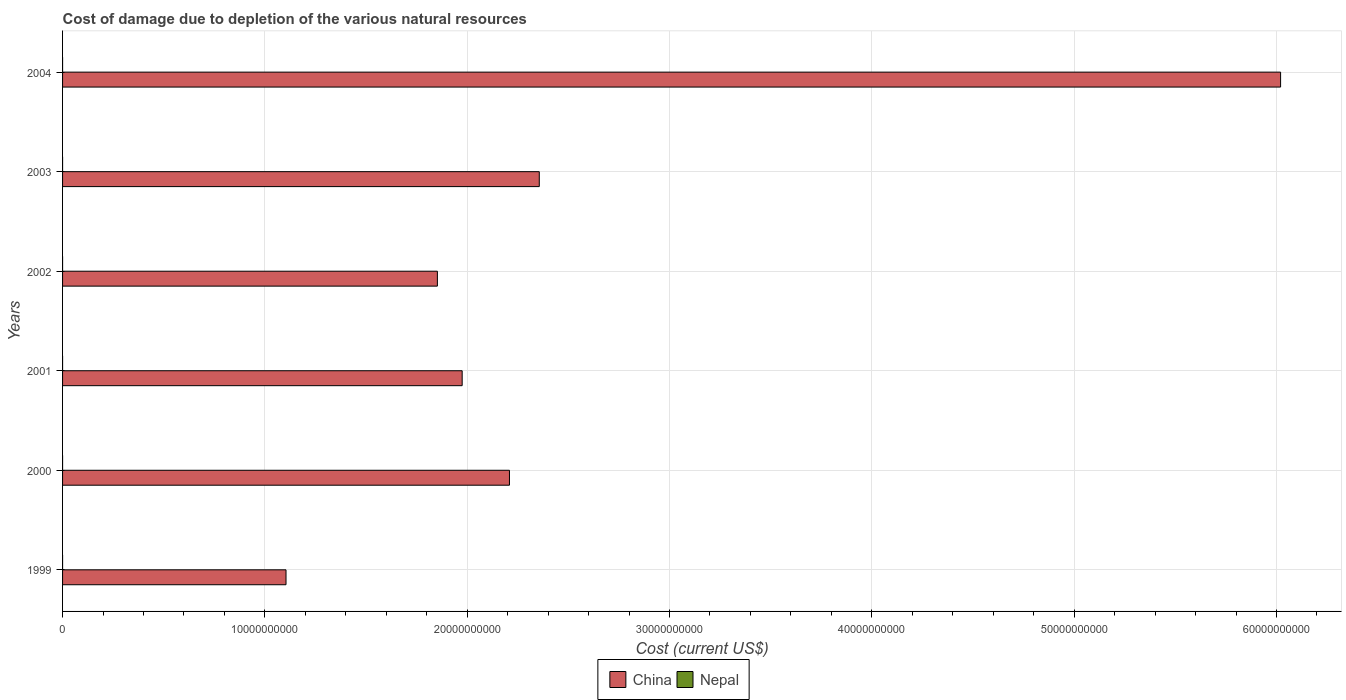How many different coloured bars are there?
Keep it short and to the point. 2. How many groups of bars are there?
Provide a succinct answer. 6. What is the cost of damage caused due to the depletion of various natural resources in China in 2004?
Your answer should be compact. 6.02e+1. Across all years, what is the maximum cost of damage caused due to the depletion of various natural resources in China?
Offer a terse response. 6.02e+1. Across all years, what is the minimum cost of damage caused due to the depletion of various natural resources in Nepal?
Ensure brevity in your answer.  4670.54. In which year was the cost of damage caused due to the depletion of various natural resources in Nepal maximum?
Your answer should be very brief. 2004. In which year was the cost of damage caused due to the depletion of various natural resources in Nepal minimum?
Ensure brevity in your answer.  1999. What is the total cost of damage caused due to the depletion of various natural resources in China in the graph?
Your answer should be compact. 1.55e+11. What is the difference between the cost of damage caused due to the depletion of various natural resources in Nepal in 1999 and that in 2001?
Offer a terse response. -5.87e+04. What is the difference between the cost of damage caused due to the depletion of various natural resources in Nepal in 2000 and the cost of damage caused due to the depletion of various natural resources in China in 2001?
Your answer should be very brief. -1.98e+1. What is the average cost of damage caused due to the depletion of various natural resources in Nepal per year?
Provide a short and direct response. 5.48e+04. In the year 2001, what is the difference between the cost of damage caused due to the depletion of various natural resources in China and cost of damage caused due to the depletion of various natural resources in Nepal?
Ensure brevity in your answer.  1.98e+1. In how many years, is the cost of damage caused due to the depletion of various natural resources in Nepal greater than 60000000000 US$?
Your answer should be compact. 0. What is the ratio of the cost of damage caused due to the depletion of various natural resources in Nepal in 2001 to that in 2003?
Your answer should be compact. 1.49. Is the cost of damage caused due to the depletion of various natural resources in Nepal in 2000 less than that in 2001?
Keep it short and to the point. Yes. Is the difference between the cost of damage caused due to the depletion of various natural resources in China in 2001 and 2002 greater than the difference between the cost of damage caused due to the depletion of various natural resources in Nepal in 2001 and 2002?
Keep it short and to the point. Yes. What is the difference between the highest and the second highest cost of damage caused due to the depletion of various natural resources in Nepal?
Offer a very short reply. 1.03e+05. What is the difference between the highest and the lowest cost of damage caused due to the depletion of various natural resources in China?
Offer a very short reply. 4.92e+1. In how many years, is the cost of damage caused due to the depletion of various natural resources in China greater than the average cost of damage caused due to the depletion of various natural resources in China taken over all years?
Your response must be concise. 1. Is the sum of the cost of damage caused due to the depletion of various natural resources in Nepal in 2000 and 2001 greater than the maximum cost of damage caused due to the depletion of various natural resources in China across all years?
Provide a short and direct response. No. What does the 2nd bar from the top in 2000 represents?
Offer a terse response. China. What does the 2nd bar from the bottom in 2004 represents?
Ensure brevity in your answer.  Nepal. How many bars are there?
Offer a very short reply. 12. Are all the bars in the graph horizontal?
Ensure brevity in your answer.  Yes. How many years are there in the graph?
Your answer should be compact. 6. What is the difference between two consecutive major ticks on the X-axis?
Provide a short and direct response. 1.00e+1. Where does the legend appear in the graph?
Ensure brevity in your answer.  Bottom center. How many legend labels are there?
Your response must be concise. 2. What is the title of the graph?
Keep it short and to the point. Cost of damage due to depletion of the various natural resources. Does "Antigua and Barbuda" appear as one of the legend labels in the graph?
Give a very brief answer. No. What is the label or title of the X-axis?
Offer a very short reply. Cost (current US$). What is the label or title of the Y-axis?
Your answer should be compact. Years. What is the Cost (current US$) of China in 1999?
Make the answer very short. 1.10e+1. What is the Cost (current US$) of Nepal in 1999?
Provide a short and direct response. 4670.54. What is the Cost (current US$) in China in 2000?
Your response must be concise. 2.21e+1. What is the Cost (current US$) of Nepal in 2000?
Your response must be concise. 2.08e+04. What is the Cost (current US$) of China in 2001?
Make the answer very short. 1.98e+1. What is the Cost (current US$) in Nepal in 2001?
Ensure brevity in your answer.  6.34e+04. What is the Cost (current US$) in China in 2002?
Ensure brevity in your answer.  1.85e+1. What is the Cost (current US$) of Nepal in 2002?
Offer a terse response. 3.04e+04. What is the Cost (current US$) in China in 2003?
Your answer should be very brief. 2.36e+1. What is the Cost (current US$) of Nepal in 2003?
Provide a short and direct response. 4.26e+04. What is the Cost (current US$) of China in 2004?
Give a very brief answer. 6.02e+1. What is the Cost (current US$) in Nepal in 2004?
Offer a terse response. 1.67e+05. Across all years, what is the maximum Cost (current US$) of China?
Offer a terse response. 6.02e+1. Across all years, what is the maximum Cost (current US$) of Nepal?
Offer a very short reply. 1.67e+05. Across all years, what is the minimum Cost (current US$) in China?
Your answer should be very brief. 1.10e+1. Across all years, what is the minimum Cost (current US$) of Nepal?
Offer a very short reply. 4670.54. What is the total Cost (current US$) of China in the graph?
Your answer should be very brief. 1.55e+11. What is the total Cost (current US$) of Nepal in the graph?
Ensure brevity in your answer.  3.29e+05. What is the difference between the Cost (current US$) in China in 1999 and that in 2000?
Your response must be concise. -1.10e+1. What is the difference between the Cost (current US$) in Nepal in 1999 and that in 2000?
Offer a terse response. -1.61e+04. What is the difference between the Cost (current US$) in China in 1999 and that in 2001?
Keep it short and to the point. -8.71e+09. What is the difference between the Cost (current US$) in Nepal in 1999 and that in 2001?
Offer a terse response. -5.87e+04. What is the difference between the Cost (current US$) of China in 1999 and that in 2002?
Offer a very short reply. -7.48e+09. What is the difference between the Cost (current US$) in Nepal in 1999 and that in 2002?
Provide a succinct answer. -2.57e+04. What is the difference between the Cost (current US$) of China in 1999 and that in 2003?
Offer a terse response. -1.25e+1. What is the difference between the Cost (current US$) of Nepal in 1999 and that in 2003?
Make the answer very short. -3.80e+04. What is the difference between the Cost (current US$) in China in 1999 and that in 2004?
Your answer should be very brief. -4.92e+1. What is the difference between the Cost (current US$) of Nepal in 1999 and that in 2004?
Offer a very short reply. -1.62e+05. What is the difference between the Cost (current US$) in China in 2000 and that in 2001?
Your answer should be compact. 2.34e+09. What is the difference between the Cost (current US$) in Nepal in 2000 and that in 2001?
Provide a succinct answer. -4.26e+04. What is the difference between the Cost (current US$) of China in 2000 and that in 2002?
Provide a succinct answer. 3.56e+09. What is the difference between the Cost (current US$) in Nepal in 2000 and that in 2002?
Keep it short and to the point. -9610.43. What is the difference between the Cost (current US$) of China in 2000 and that in 2003?
Give a very brief answer. -1.47e+09. What is the difference between the Cost (current US$) of Nepal in 2000 and that in 2003?
Give a very brief answer. -2.19e+04. What is the difference between the Cost (current US$) of China in 2000 and that in 2004?
Your answer should be compact. -3.81e+1. What is the difference between the Cost (current US$) in Nepal in 2000 and that in 2004?
Offer a terse response. -1.46e+05. What is the difference between the Cost (current US$) of China in 2001 and that in 2002?
Offer a very short reply. 1.23e+09. What is the difference between the Cost (current US$) in Nepal in 2001 and that in 2002?
Keep it short and to the point. 3.30e+04. What is the difference between the Cost (current US$) of China in 2001 and that in 2003?
Ensure brevity in your answer.  -3.81e+09. What is the difference between the Cost (current US$) of Nepal in 2001 and that in 2003?
Your answer should be compact. 2.08e+04. What is the difference between the Cost (current US$) of China in 2001 and that in 2004?
Offer a very short reply. -4.05e+1. What is the difference between the Cost (current US$) of Nepal in 2001 and that in 2004?
Your response must be concise. -1.03e+05. What is the difference between the Cost (current US$) of China in 2002 and that in 2003?
Offer a terse response. -5.04e+09. What is the difference between the Cost (current US$) in Nepal in 2002 and that in 2003?
Provide a succinct answer. -1.23e+04. What is the difference between the Cost (current US$) of China in 2002 and that in 2004?
Your answer should be compact. -4.17e+1. What is the difference between the Cost (current US$) of Nepal in 2002 and that in 2004?
Provide a short and direct response. -1.37e+05. What is the difference between the Cost (current US$) in China in 2003 and that in 2004?
Keep it short and to the point. -3.66e+1. What is the difference between the Cost (current US$) in Nepal in 2003 and that in 2004?
Give a very brief answer. -1.24e+05. What is the difference between the Cost (current US$) of China in 1999 and the Cost (current US$) of Nepal in 2000?
Provide a succinct answer. 1.10e+1. What is the difference between the Cost (current US$) in China in 1999 and the Cost (current US$) in Nepal in 2001?
Ensure brevity in your answer.  1.10e+1. What is the difference between the Cost (current US$) of China in 1999 and the Cost (current US$) of Nepal in 2002?
Keep it short and to the point. 1.10e+1. What is the difference between the Cost (current US$) of China in 1999 and the Cost (current US$) of Nepal in 2003?
Ensure brevity in your answer.  1.10e+1. What is the difference between the Cost (current US$) in China in 1999 and the Cost (current US$) in Nepal in 2004?
Your response must be concise. 1.10e+1. What is the difference between the Cost (current US$) of China in 2000 and the Cost (current US$) of Nepal in 2001?
Ensure brevity in your answer.  2.21e+1. What is the difference between the Cost (current US$) in China in 2000 and the Cost (current US$) in Nepal in 2002?
Keep it short and to the point. 2.21e+1. What is the difference between the Cost (current US$) of China in 2000 and the Cost (current US$) of Nepal in 2003?
Provide a succinct answer. 2.21e+1. What is the difference between the Cost (current US$) of China in 2000 and the Cost (current US$) of Nepal in 2004?
Make the answer very short. 2.21e+1. What is the difference between the Cost (current US$) in China in 2001 and the Cost (current US$) in Nepal in 2002?
Provide a short and direct response. 1.98e+1. What is the difference between the Cost (current US$) of China in 2001 and the Cost (current US$) of Nepal in 2003?
Your response must be concise. 1.98e+1. What is the difference between the Cost (current US$) in China in 2001 and the Cost (current US$) in Nepal in 2004?
Provide a short and direct response. 1.98e+1. What is the difference between the Cost (current US$) of China in 2002 and the Cost (current US$) of Nepal in 2003?
Make the answer very short. 1.85e+1. What is the difference between the Cost (current US$) in China in 2002 and the Cost (current US$) in Nepal in 2004?
Your response must be concise. 1.85e+1. What is the difference between the Cost (current US$) in China in 2003 and the Cost (current US$) in Nepal in 2004?
Provide a short and direct response. 2.36e+1. What is the average Cost (current US$) in China per year?
Provide a succinct answer. 2.59e+1. What is the average Cost (current US$) of Nepal per year?
Your answer should be compact. 5.48e+04. In the year 1999, what is the difference between the Cost (current US$) of China and Cost (current US$) of Nepal?
Make the answer very short. 1.10e+1. In the year 2000, what is the difference between the Cost (current US$) in China and Cost (current US$) in Nepal?
Provide a succinct answer. 2.21e+1. In the year 2001, what is the difference between the Cost (current US$) of China and Cost (current US$) of Nepal?
Give a very brief answer. 1.98e+1. In the year 2002, what is the difference between the Cost (current US$) in China and Cost (current US$) in Nepal?
Provide a succinct answer. 1.85e+1. In the year 2003, what is the difference between the Cost (current US$) in China and Cost (current US$) in Nepal?
Your response must be concise. 2.36e+1. In the year 2004, what is the difference between the Cost (current US$) of China and Cost (current US$) of Nepal?
Your answer should be compact. 6.02e+1. What is the ratio of the Cost (current US$) of Nepal in 1999 to that in 2000?
Give a very brief answer. 0.22. What is the ratio of the Cost (current US$) in China in 1999 to that in 2001?
Provide a short and direct response. 0.56. What is the ratio of the Cost (current US$) of Nepal in 1999 to that in 2001?
Give a very brief answer. 0.07. What is the ratio of the Cost (current US$) in China in 1999 to that in 2002?
Your response must be concise. 0.6. What is the ratio of the Cost (current US$) in Nepal in 1999 to that in 2002?
Provide a short and direct response. 0.15. What is the ratio of the Cost (current US$) in China in 1999 to that in 2003?
Offer a very short reply. 0.47. What is the ratio of the Cost (current US$) of Nepal in 1999 to that in 2003?
Provide a succinct answer. 0.11. What is the ratio of the Cost (current US$) of China in 1999 to that in 2004?
Make the answer very short. 0.18. What is the ratio of the Cost (current US$) in Nepal in 1999 to that in 2004?
Provide a succinct answer. 0.03. What is the ratio of the Cost (current US$) of China in 2000 to that in 2001?
Offer a terse response. 1.12. What is the ratio of the Cost (current US$) in Nepal in 2000 to that in 2001?
Keep it short and to the point. 0.33. What is the ratio of the Cost (current US$) in China in 2000 to that in 2002?
Your answer should be compact. 1.19. What is the ratio of the Cost (current US$) of Nepal in 2000 to that in 2002?
Your answer should be compact. 0.68. What is the ratio of the Cost (current US$) in China in 2000 to that in 2003?
Make the answer very short. 0.94. What is the ratio of the Cost (current US$) of Nepal in 2000 to that in 2003?
Provide a succinct answer. 0.49. What is the ratio of the Cost (current US$) in China in 2000 to that in 2004?
Make the answer very short. 0.37. What is the ratio of the Cost (current US$) in Nepal in 2000 to that in 2004?
Make the answer very short. 0.12. What is the ratio of the Cost (current US$) in China in 2001 to that in 2002?
Ensure brevity in your answer.  1.07. What is the ratio of the Cost (current US$) in Nepal in 2001 to that in 2002?
Ensure brevity in your answer.  2.09. What is the ratio of the Cost (current US$) in China in 2001 to that in 2003?
Offer a very short reply. 0.84. What is the ratio of the Cost (current US$) of Nepal in 2001 to that in 2003?
Your answer should be very brief. 1.49. What is the ratio of the Cost (current US$) of China in 2001 to that in 2004?
Ensure brevity in your answer.  0.33. What is the ratio of the Cost (current US$) in Nepal in 2001 to that in 2004?
Offer a very short reply. 0.38. What is the ratio of the Cost (current US$) of China in 2002 to that in 2003?
Give a very brief answer. 0.79. What is the ratio of the Cost (current US$) in Nepal in 2002 to that in 2003?
Provide a short and direct response. 0.71. What is the ratio of the Cost (current US$) of China in 2002 to that in 2004?
Keep it short and to the point. 0.31. What is the ratio of the Cost (current US$) in Nepal in 2002 to that in 2004?
Make the answer very short. 0.18. What is the ratio of the Cost (current US$) in China in 2003 to that in 2004?
Keep it short and to the point. 0.39. What is the ratio of the Cost (current US$) in Nepal in 2003 to that in 2004?
Provide a short and direct response. 0.26. What is the difference between the highest and the second highest Cost (current US$) of China?
Offer a terse response. 3.66e+1. What is the difference between the highest and the second highest Cost (current US$) in Nepal?
Your answer should be very brief. 1.03e+05. What is the difference between the highest and the lowest Cost (current US$) of China?
Ensure brevity in your answer.  4.92e+1. What is the difference between the highest and the lowest Cost (current US$) in Nepal?
Your answer should be very brief. 1.62e+05. 